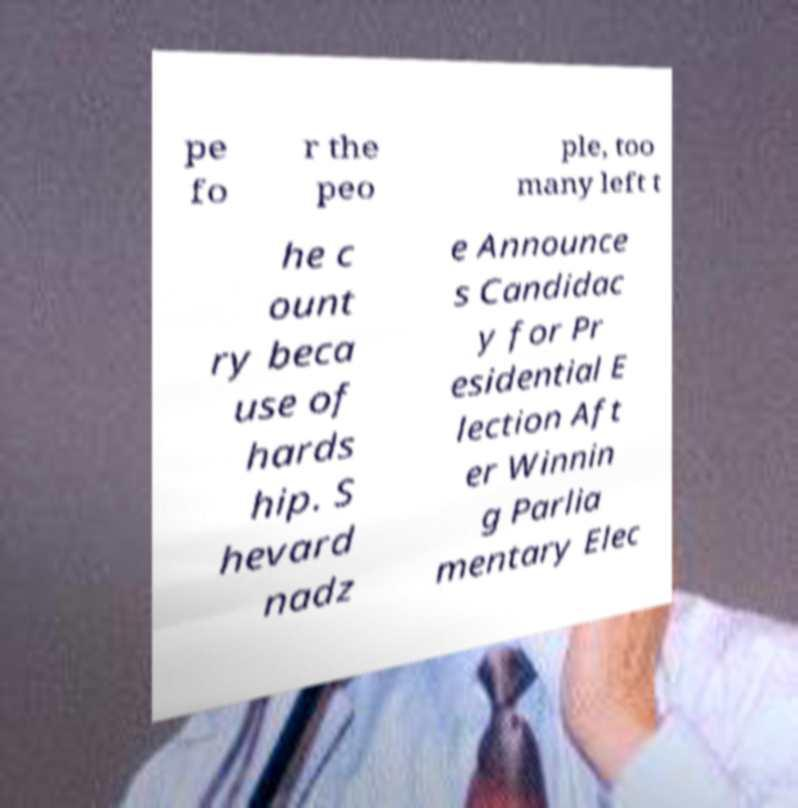Please identify and transcribe the text found in this image. pe fo r the peo ple, too many left t he c ount ry beca use of hards hip. S hevard nadz e Announce s Candidac y for Pr esidential E lection Aft er Winnin g Parlia mentary Elec 